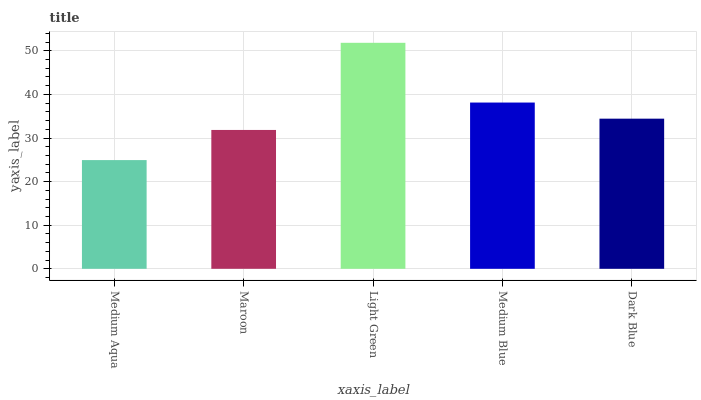Is Medium Aqua the minimum?
Answer yes or no. Yes. Is Light Green the maximum?
Answer yes or no. Yes. Is Maroon the minimum?
Answer yes or no. No. Is Maroon the maximum?
Answer yes or no. No. Is Maroon greater than Medium Aqua?
Answer yes or no. Yes. Is Medium Aqua less than Maroon?
Answer yes or no. Yes. Is Medium Aqua greater than Maroon?
Answer yes or no. No. Is Maroon less than Medium Aqua?
Answer yes or no. No. Is Dark Blue the high median?
Answer yes or no. Yes. Is Dark Blue the low median?
Answer yes or no. Yes. Is Medium Aqua the high median?
Answer yes or no. No. Is Medium Aqua the low median?
Answer yes or no. No. 